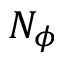Convert formula to latex. <formula><loc_0><loc_0><loc_500><loc_500>N _ { \phi }</formula> 